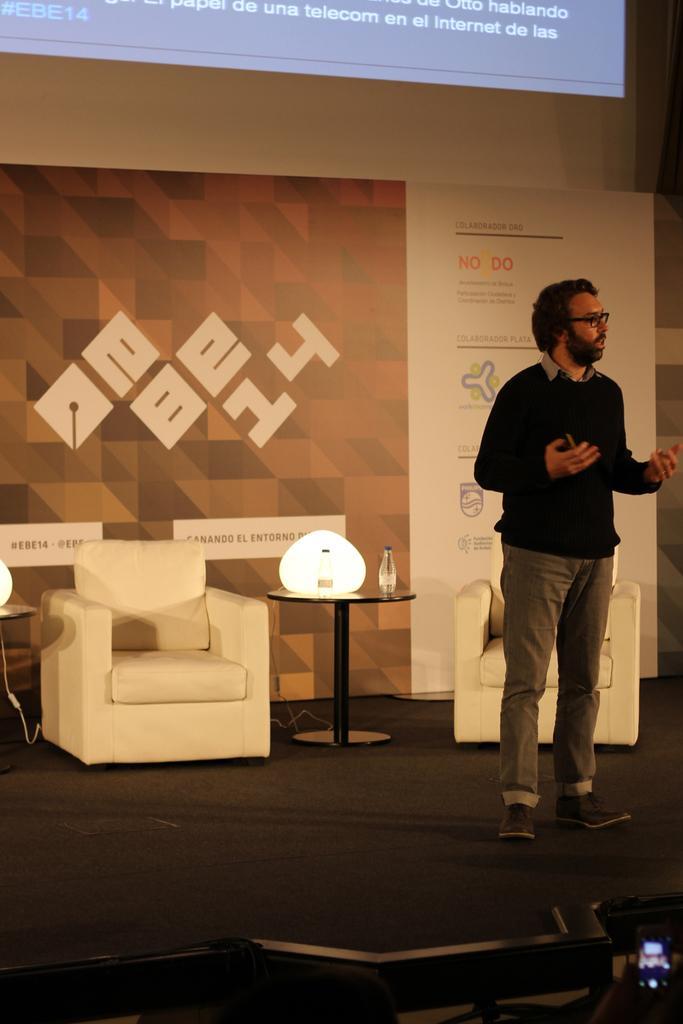Please provide a concise description of this image. In this image I see a man who is standing and in the background I see a table on which there is a bottle and a chair over here. 